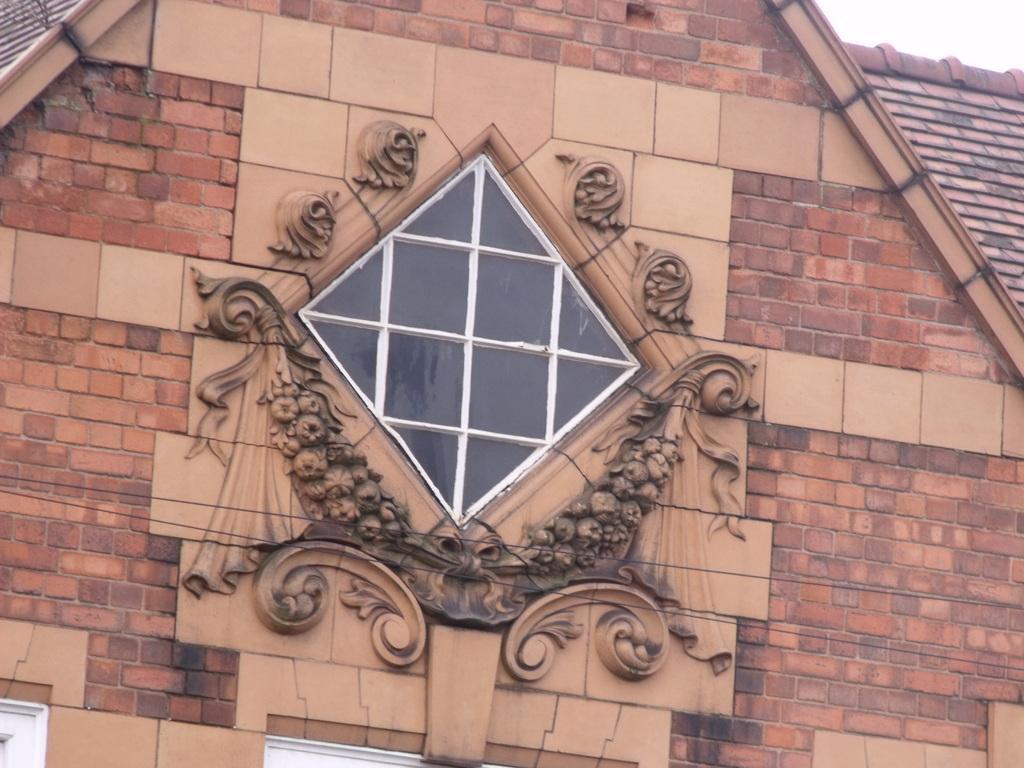Please provide a concise description of this image. In this image, we can see brick walls, carving and glass object. At the bottom of the image, we can see white color objects. 